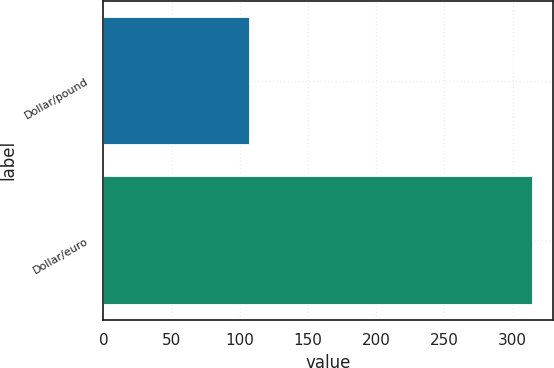<chart> <loc_0><loc_0><loc_500><loc_500><bar_chart><fcel>Dollar/pound<fcel>Dollar/euro<nl><fcel>107<fcel>314<nl></chart> 